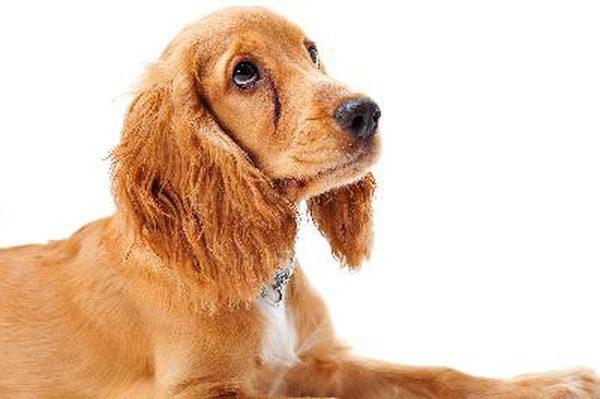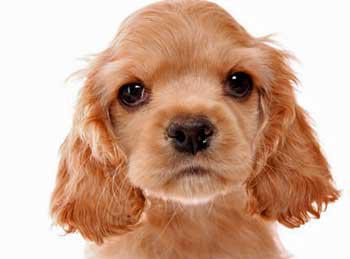The first image is the image on the left, the second image is the image on the right. Given the left and right images, does the statement "One of the dogs is near the grass." hold true? Answer yes or no. No. 